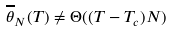<formula> <loc_0><loc_0><loc_500><loc_500>\overline { \theta } _ { N } ( T ) \neq \Theta ( ( T - T _ { c } ) N )</formula> 